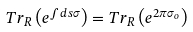Convert formula to latex. <formula><loc_0><loc_0><loc_500><loc_500>T r _ { R } \left ( e ^ { \int d s \sigma } \right ) = T r _ { R } \left ( e ^ { 2 \pi \sigma _ { o } } \right )</formula> 